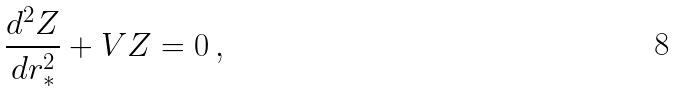Convert formula to latex. <formula><loc_0><loc_0><loc_500><loc_500>\frac { d ^ { 2 } Z } { d r _ { * } ^ { 2 } } + V Z = 0 \, ,</formula> 